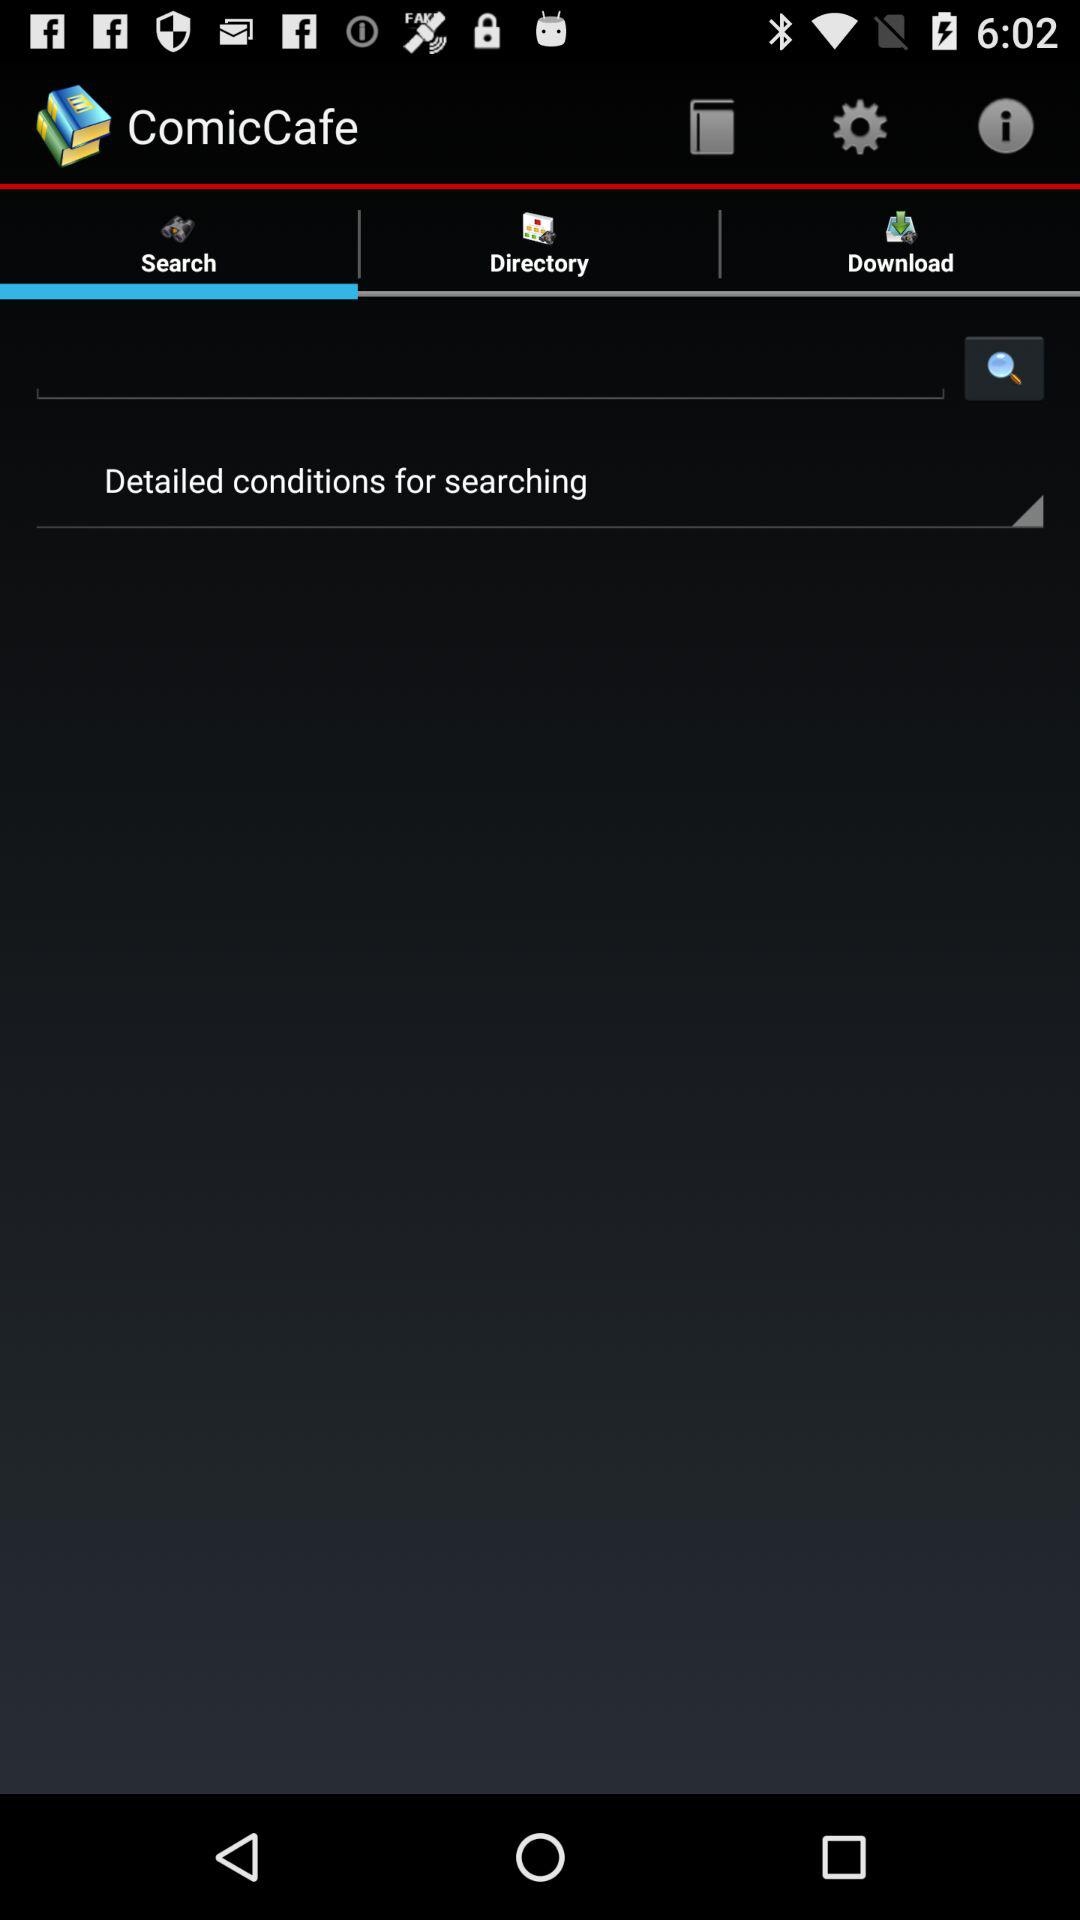Which option is selected in "ComicCafe"? The selected option is "Search". 